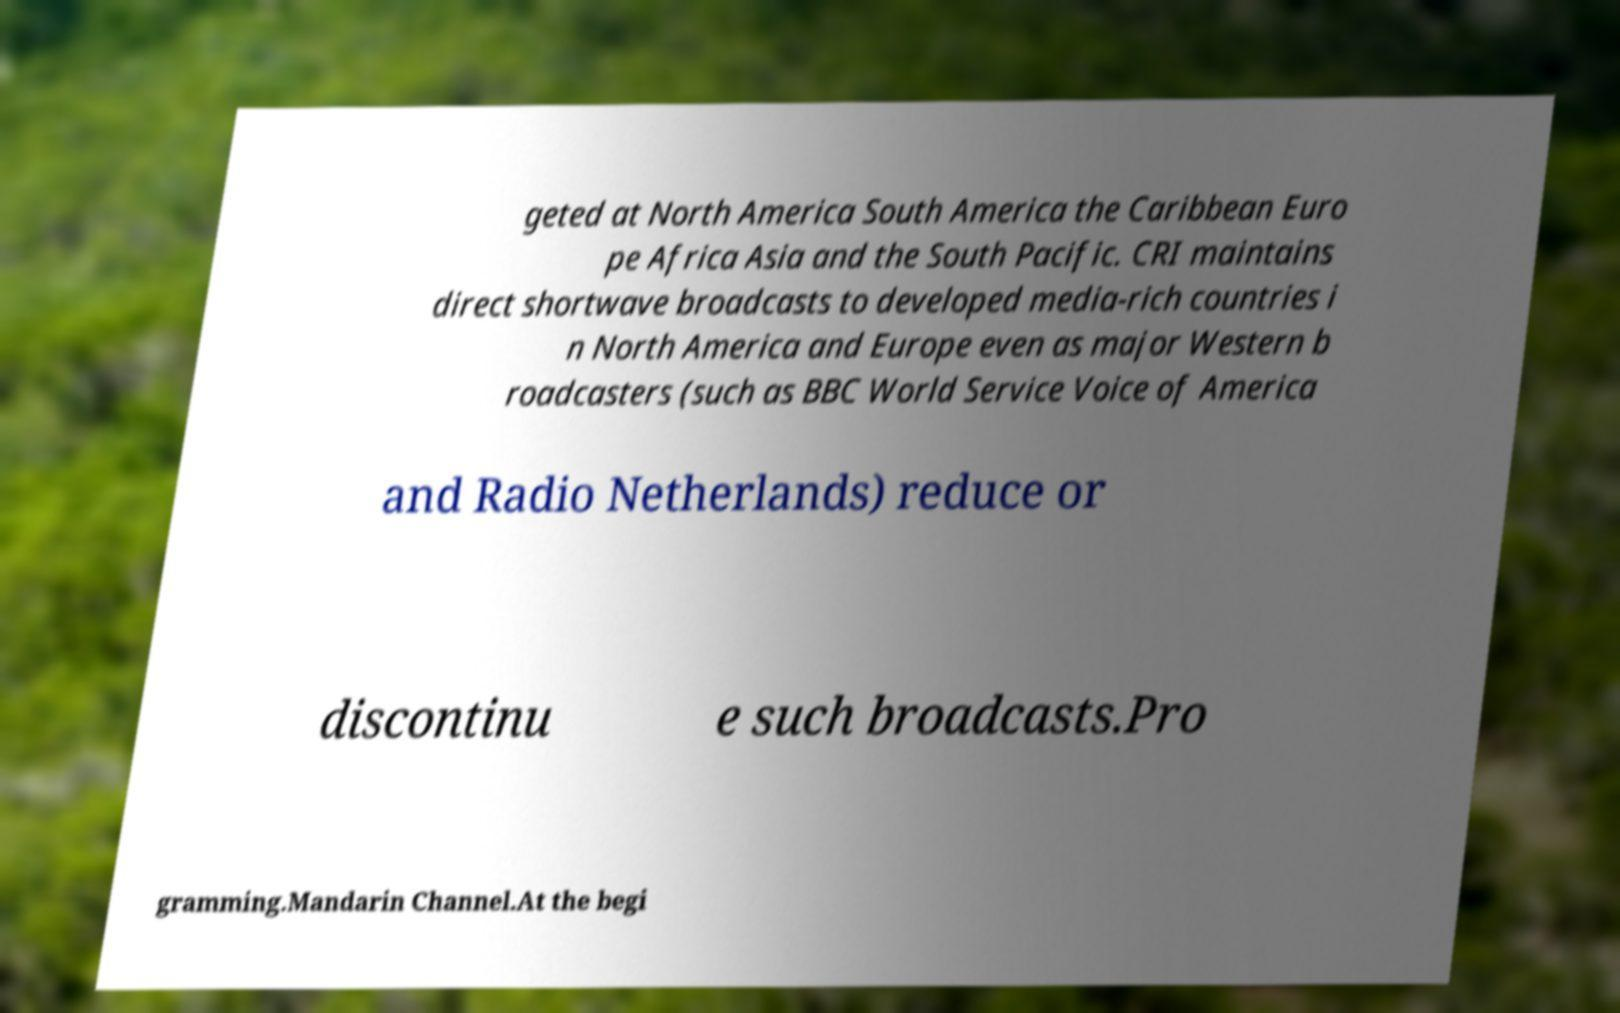Could you assist in decoding the text presented in this image and type it out clearly? geted at North America South America the Caribbean Euro pe Africa Asia and the South Pacific. CRI maintains direct shortwave broadcasts to developed media-rich countries i n North America and Europe even as major Western b roadcasters (such as BBC World Service Voice of America and Radio Netherlands) reduce or discontinu e such broadcasts.Pro gramming.Mandarin Channel.At the begi 